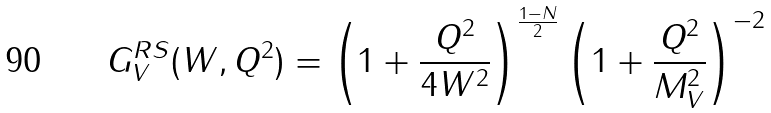Convert formula to latex. <formula><loc_0><loc_0><loc_500><loc_500>G _ { V } ^ { R S } ( W , Q ^ { 2 } ) = \left ( 1 + \frac { Q ^ { 2 } } { 4 W ^ { 2 } } \right ) ^ { \frac { 1 - N } { 2 } } \left ( 1 + \frac { Q ^ { 2 } } { M _ { V } ^ { 2 } } \right ) ^ { - 2 }</formula> 